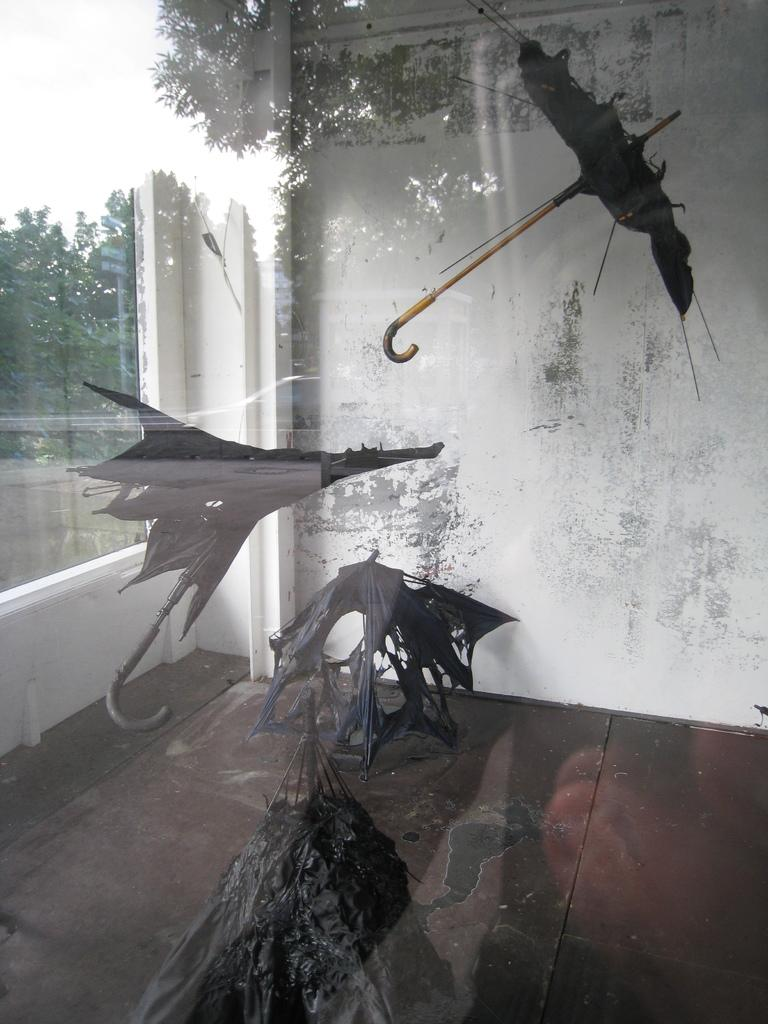What is the main subject of the image? The main subject of the image is a view from a glass. What can be seen in the view? The view includes a wall and a broken umbrella outside the window. What else is visible outside the window? Trees are present outside the window. What type of sock is being worn by the team in the image? There is no sock or team present in the image; it features a view from a glass with a wall, a broken umbrella, and trees outside the window. What toy is being played with by the children in the image? There are no children or toys present in the image. 